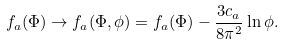<formula> <loc_0><loc_0><loc_500><loc_500>f _ { a } ( \Phi ) \rightarrow f _ { a } ( \Phi , \phi ) = f _ { a } ( \Phi ) - \frac { 3 c _ { a } } { 8 \pi ^ { 2 } } \ln \phi .</formula> 